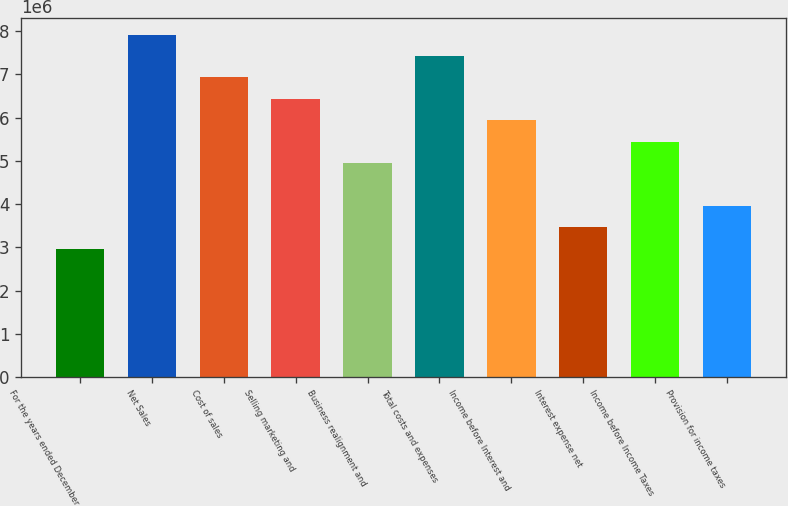Convert chart to OTSL. <chart><loc_0><loc_0><loc_500><loc_500><bar_chart><fcel>For the years ended December<fcel>Net Sales<fcel>Cost of sales<fcel>Selling marketing and<fcel>Business realignment and<fcel>Total costs and expenses<fcel>Income before Interest and<fcel>Interest expense net<fcel>Income before Income Taxes<fcel>Provision for income taxes<nl><fcel>2.96803e+06<fcel>7.91475e+06<fcel>6.9254e+06<fcel>6.43073e+06<fcel>4.94672e+06<fcel>7.42007e+06<fcel>5.93606e+06<fcel>3.4627e+06<fcel>5.44139e+06<fcel>3.95737e+06<nl></chart> 